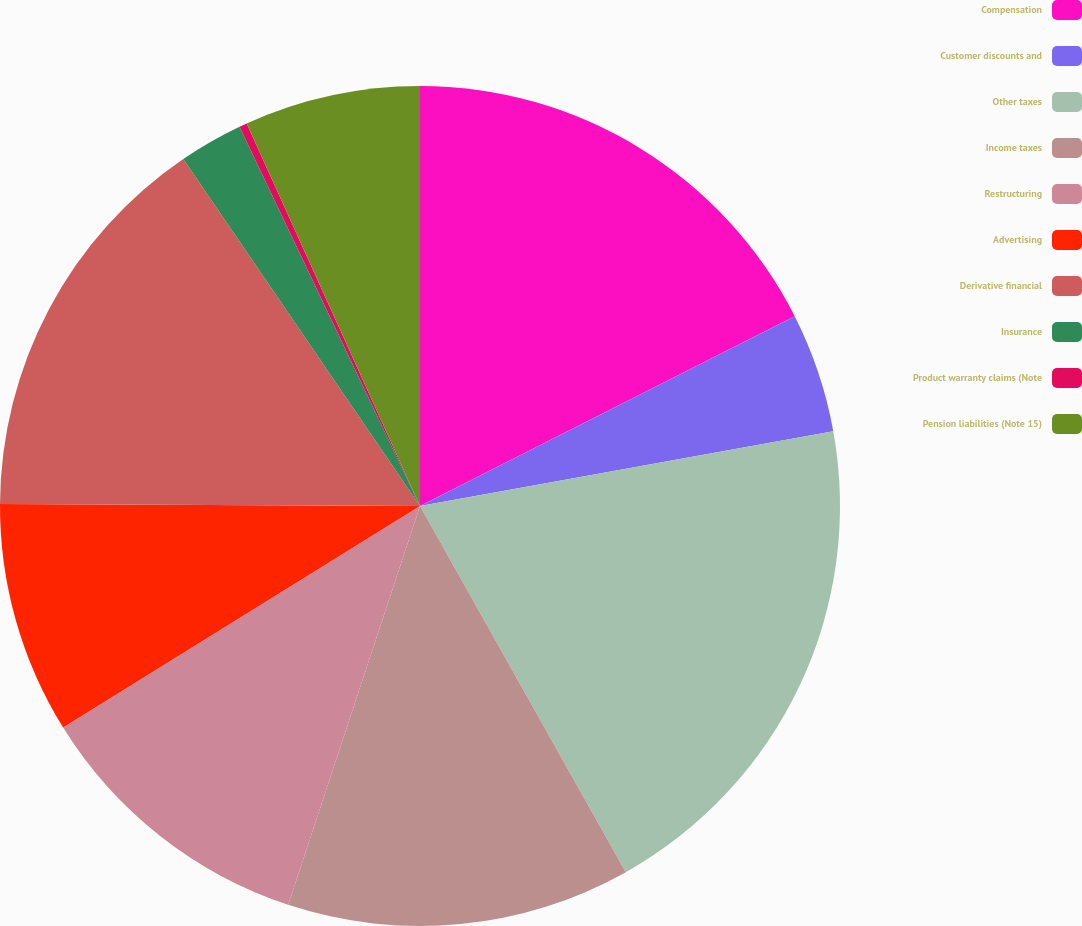Convert chart to OTSL. <chart><loc_0><loc_0><loc_500><loc_500><pie_chart><fcel>Compensation<fcel>Customer discounts and<fcel>Other taxes<fcel>Income taxes<fcel>Restructuring<fcel>Advertising<fcel>Derivative financial<fcel>Insurance<fcel>Product warranty claims (Note<fcel>Pension liabilities (Note 15)<nl><fcel>17.54%<fcel>4.61%<fcel>19.7%<fcel>13.23%<fcel>11.08%<fcel>8.92%<fcel>15.39%<fcel>2.46%<fcel>0.3%<fcel>6.77%<nl></chart> 